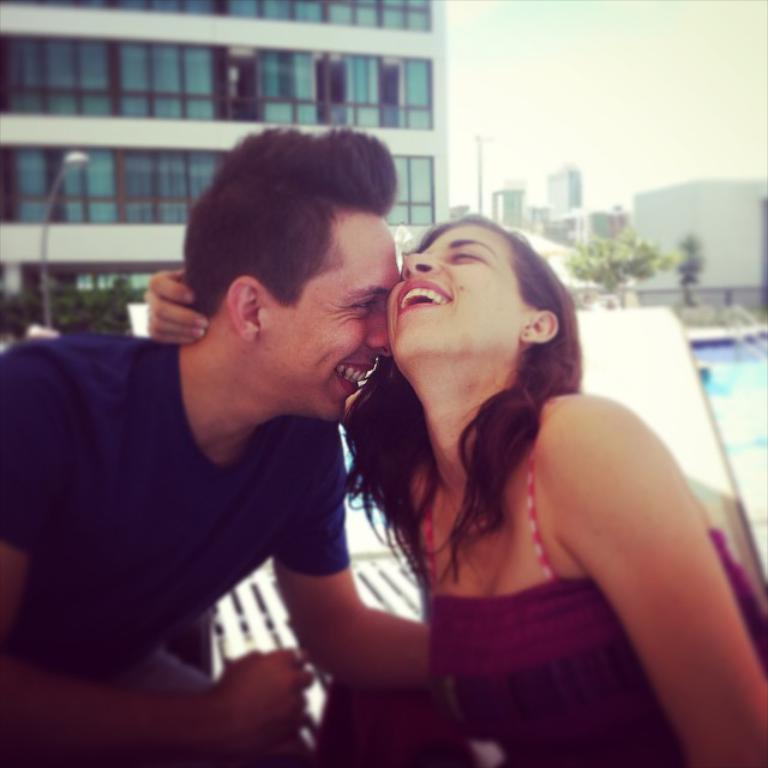Who are the people in the foreground of the image? There is a man and a woman in the foreground of the image. What can be seen in the background of the image? There are buildings, trees, a swimming pool, poles, and the sky visible in the background of the image. What type of straw is the man using to drink from the cap in the image? There is no straw or cap present in the image. 